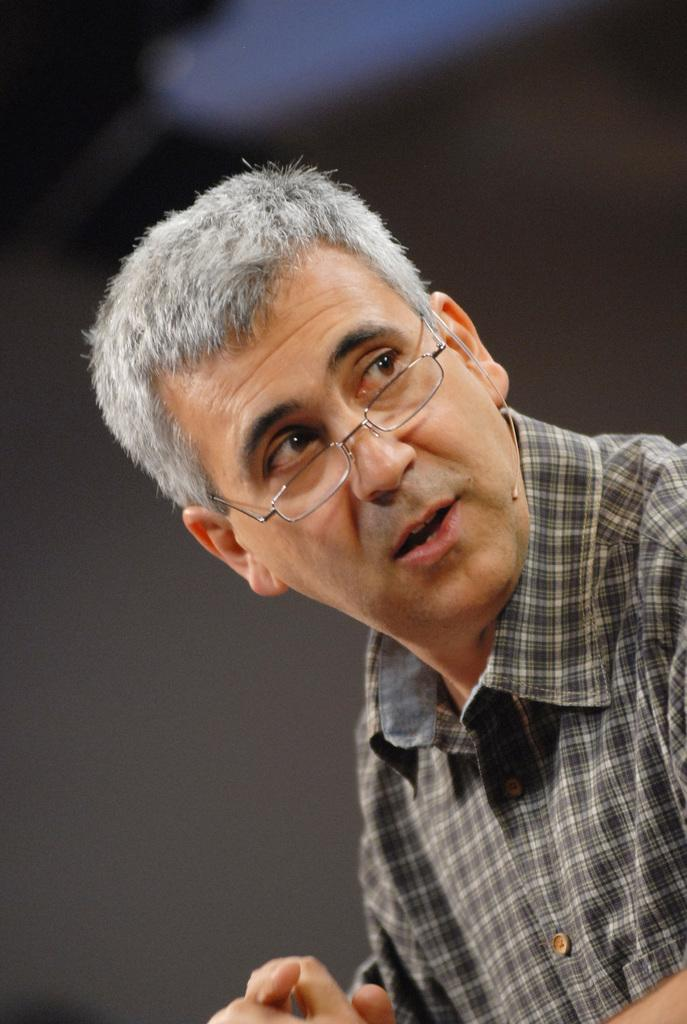Who is the main subject in the image? There is a man in the front of the image. What is the man wearing? The man is wearing a shirt and spectacles. Can you describe the background of the image? The background of the image is blurry. What type of noise can be heard coming from the owl in the image? There is no owl present in the image, so it is not possible to determine what, if any, noise might be heard. 